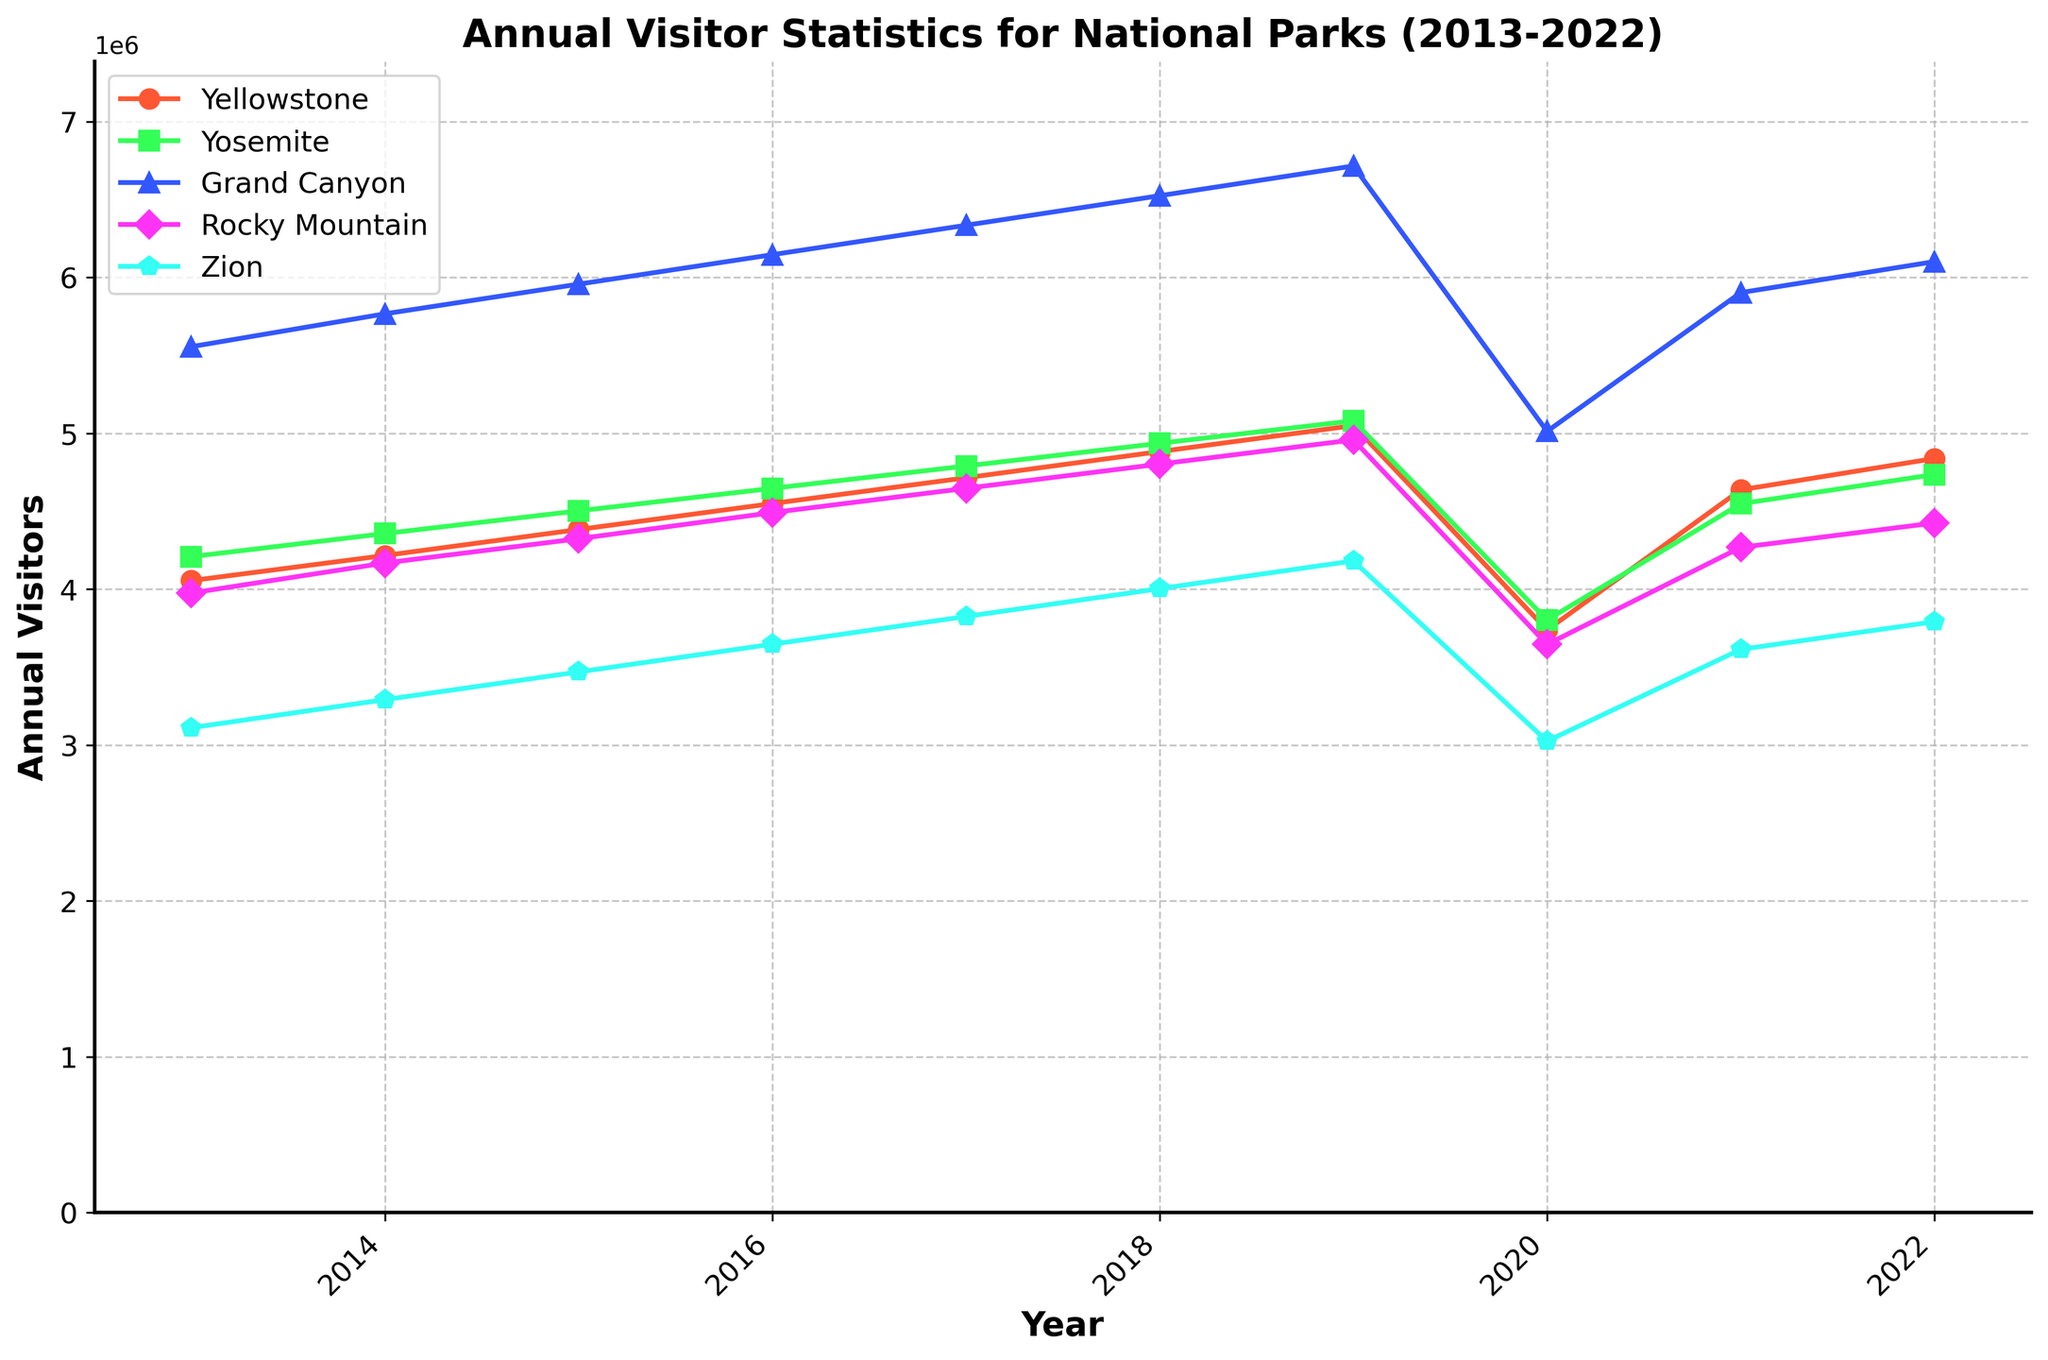Which national park had the highest number of visitors in 2018? Look for the peak value in the plotted lines for the year 2018 and identify the corresponding park. The park with the highest visitor number in 2018 is represented by the line with the highest point for that year.
Answer: Yellowstone Is the number of visitors to the Grand Canyon increasing or decreasing from 2013 to 2022? Observe the trend of the line representing Grand Canyon across the years 2013 to 2022. Notice whether the relative position of the line increases or decreases over time.
Answer: Increasing Which park showed the most significant increase in visitors from spring to summer in 2015? Examine the plot from spring to summer in 2015 and compare the vertical rise in each of the lines. Identify which park's line shows the greatest upward change.
Answer: Yellowstone What is the average annual visitor count for Yosemite from 2017 to 2019? Extract the number of visitors to Yosemite for each year from 2017 to 2019, then calculate the average by summing these values and dividing by the number of years. (856789 + 2465432 + 1078901 + 901234 + 2643210 + 1123456) / 3 = 1420157.
Answer: 1420157 Did any park have a year where the total visitors dropped below 400,000? Check each park's line for any point below 400,000 on the y-axis across the years. If such a point exists, identify the corresponding park and year.
Answer: Yes, Yellowstone in Winter 2020 Which park had a consistent increase in visitors every year from 2018 to 2022? Look for a park whose line increases without any dips from 2018 to 2022. Compare the annual visitor counts visually for each year.
Answer: Zion How much did the visitor count change for Rocky Mountain from summer 2013 to summer 2015? Identify the visitor counts for Rocky Mountain in summer 2013 and summer 2015. Calculate the difference by subtracting the 2013 value from the 2015 value (2187654 - 1987654 = 200000).
Answer: 200000 Which season had the lowest number of visitors across all parks in 2022? Compare the lines for all parks in the year 2022, focusing on each season. Identify the season with the lowest average across all parks.
Answer: Winter What is the percentage increase in visitors to Zion from 2014 to 2019? Calculate the visitor count for Zion in 2014 and 2019. Compute the percentage increase using the formula ((value in 2019 - value in 2014) / value in 2014) * 100. ((2434098 - 1876543) / 1876543) * 100 ≈ 29.7%.
Answer: 29.7% What's the median number of annual visitors for Grand Canyon between 2013 and 2022? Arrange the annual visitor counts for Grand Canyon in ascending order and determine the middle value. If there is an even number of them, calculate the average of the two middle values. Ordered counts: [456789, 478901, 489012, 501234, 512345, 523456, 534567, 845678, 1001234, 1023456, 1045678, 1067890, 1090123, 1112345, 1123456, 1234567, 1298765, 1345678, 1389012, 1432345, 1476543, 1521987]. Median = 1090123.
Answer: 1090123 